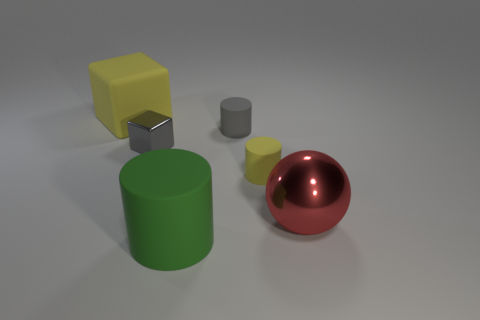Subtract all tiny yellow cylinders. How many cylinders are left? 2 Subtract all gray cubes. How many cubes are left? 1 Add 3 large red matte cylinders. How many objects exist? 9 Subtract all blocks. How many objects are left? 4 Add 2 matte cylinders. How many matte cylinders are left? 5 Add 1 yellow cylinders. How many yellow cylinders exist? 2 Subtract 1 yellow blocks. How many objects are left? 5 Subtract all red cylinders. Subtract all cyan balls. How many cylinders are left? 3 Subtract all big metal things. Subtract all small cylinders. How many objects are left? 3 